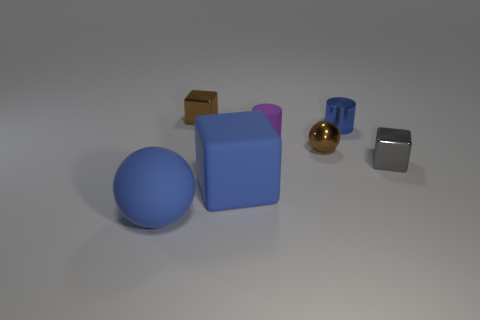What number of things are rubber cylinders or tiny metallic things that are on the left side of the small blue shiny object? Upon inspection of the image, there appears to be one rubber cylinder and two small metallic objects on the left side of the small blue shiny object, making the total count three. The metallic objects, both exhibiting a reflective surface, seem to slightly vary in size and shape. However, the initial response could benefit from a bit more clarity in this regard. 